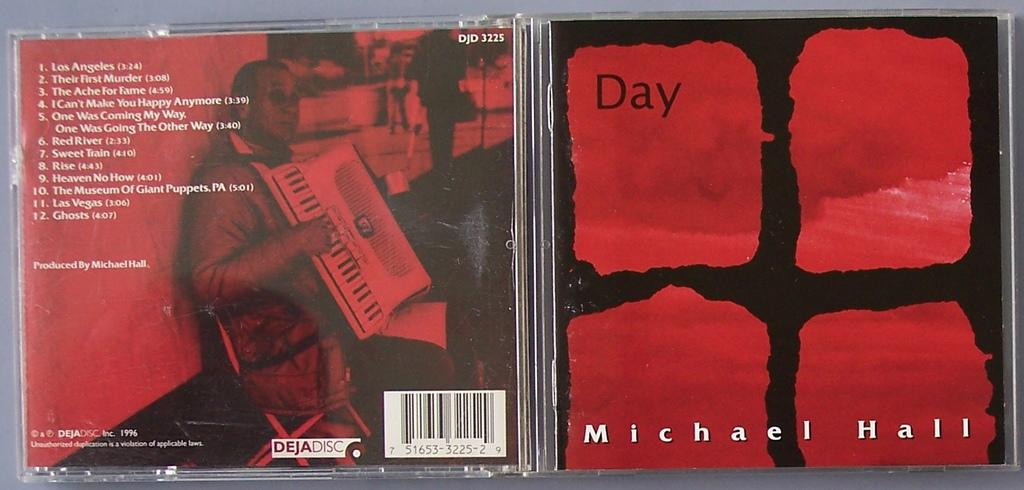<image>
Offer a succinct explanation of the picture presented. An open jewel case for a CD of Michael Hall. 